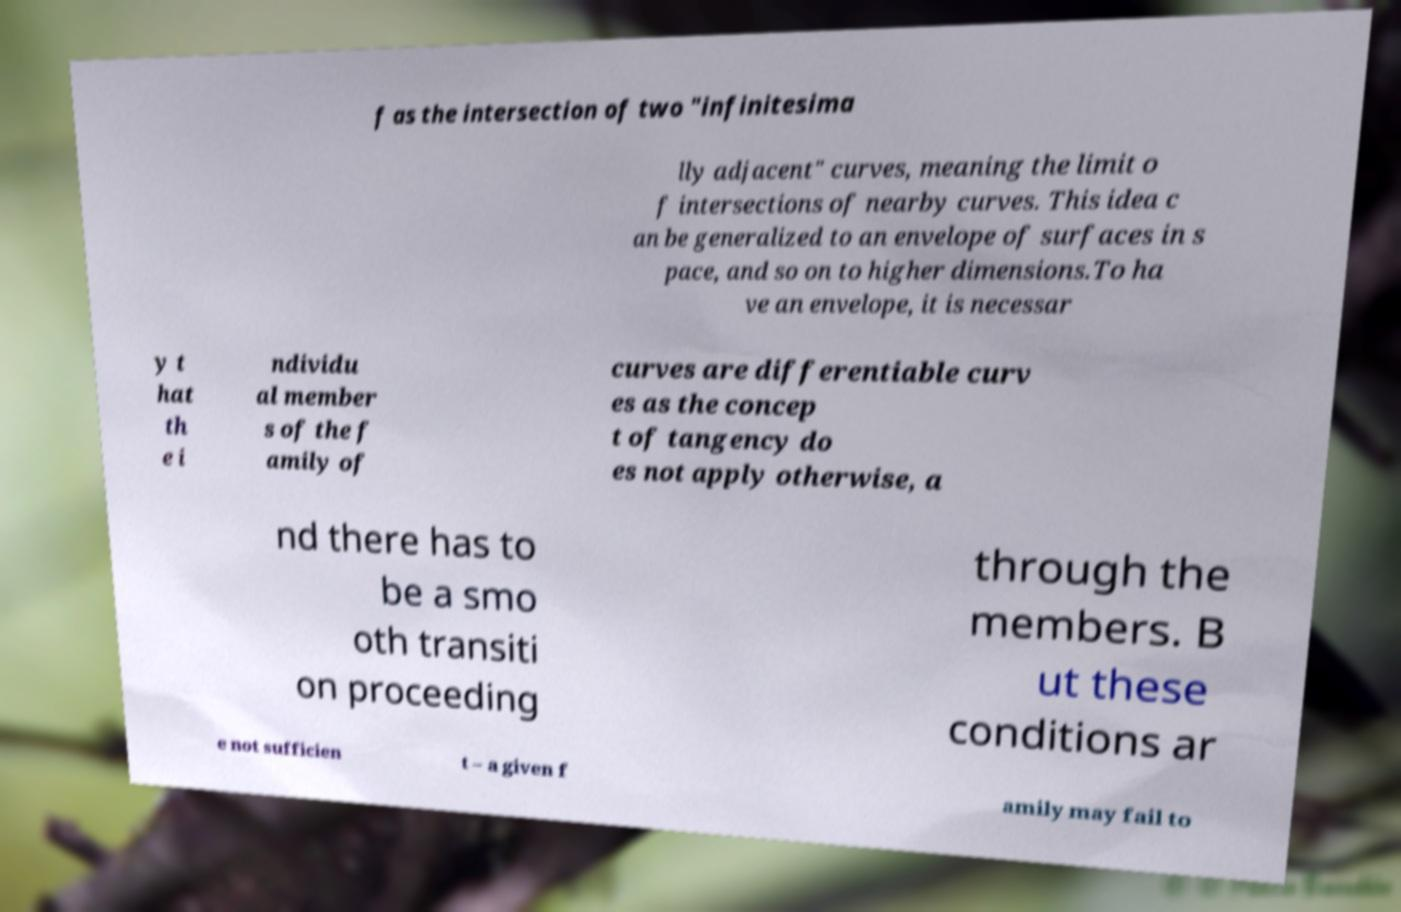Please read and relay the text visible in this image. What does it say? f as the intersection of two "infinitesima lly adjacent" curves, meaning the limit o f intersections of nearby curves. This idea c an be generalized to an envelope of surfaces in s pace, and so on to higher dimensions.To ha ve an envelope, it is necessar y t hat th e i ndividu al member s of the f amily of curves are differentiable curv es as the concep t of tangency do es not apply otherwise, a nd there has to be a smo oth transiti on proceeding through the members. B ut these conditions ar e not sufficien t – a given f amily may fail to 